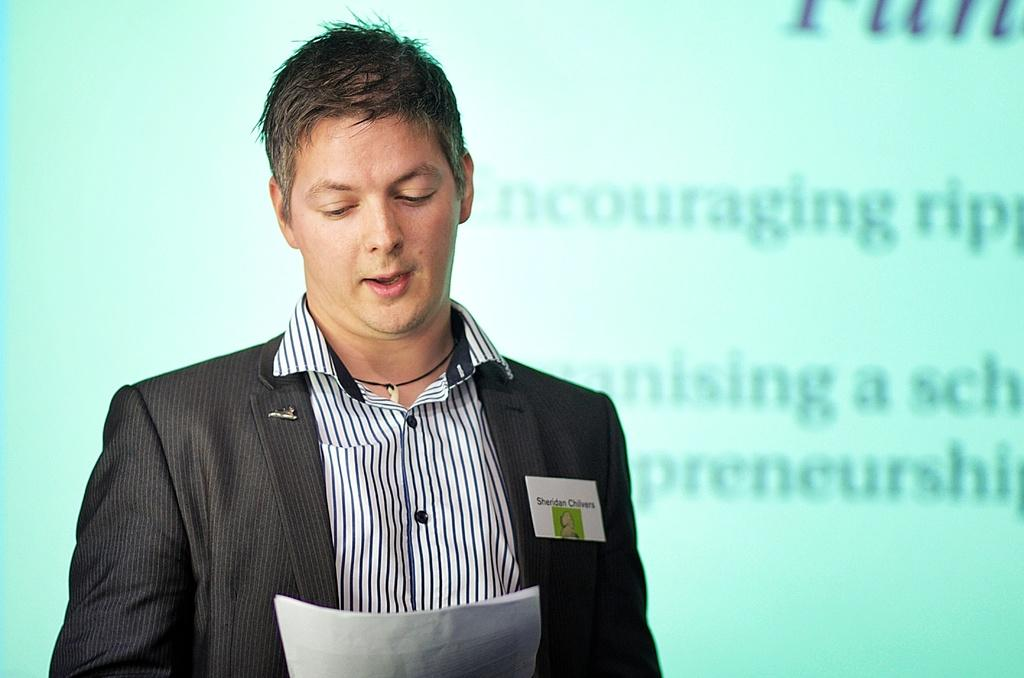Who or what is present in the image? There is a person in the image. What objects can be seen alongside the person? There are papers in the image. What can be seen in the background of the image? There is a screen in the background of the image. What is displayed on the screen? Text is visible on the screen. Can you see a rail that the person is holding onto in the image? There is no rail present in the image. 